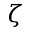<formula> <loc_0><loc_0><loc_500><loc_500>\zeta</formula> 